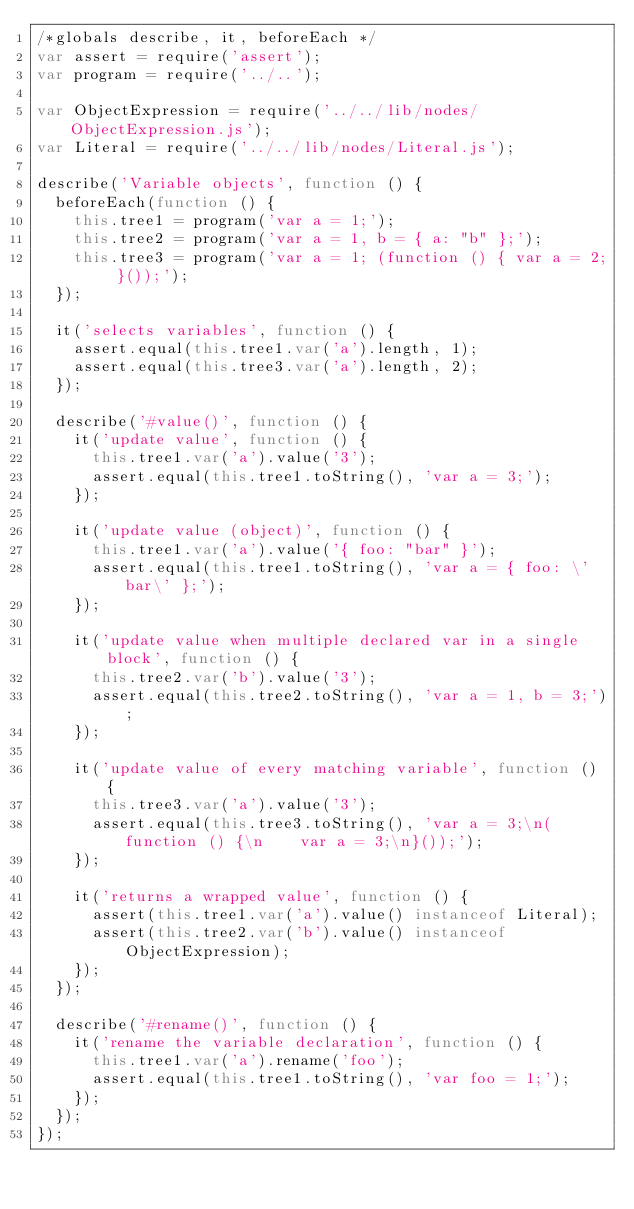<code> <loc_0><loc_0><loc_500><loc_500><_JavaScript_>/*globals describe, it, beforeEach */
var assert = require('assert');
var program = require('../..');

var ObjectExpression = require('../../lib/nodes/ObjectExpression.js');
var Literal = require('../../lib/nodes/Literal.js');

describe('Variable objects', function () {
  beforeEach(function () {
    this.tree1 = program('var a = 1;');
    this.tree2 = program('var a = 1, b = { a: "b" };');
    this.tree3 = program('var a = 1; (function () { var a = 2; }());');
  });

  it('selects variables', function () {
    assert.equal(this.tree1.var('a').length, 1);
    assert.equal(this.tree3.var('a').length, 2);
  });

  describe('#value()', function () {
    it('update value', function () {
      this.tree1.var('a').value('3');
      assert.equal(this.tree1.toString(), 'var a = 3;');
    });

    it('update value (object)', function () {
      this.tree1.var('a').value('{ foo: "bar" }');
      assert.equal(this.tree1.toString(), 'var a = { foo: \'bar\' };');
    });

    it('update value when multiple declared var in a single block', function () {
      this.tree2.var('b').value('3');
      assert.equal(this.tree2.toString(), 'var a = 1, b = 3;');
    });

    it('update value of every matching variable', function () {
      this.tree3.var('a').value('3');
      assert.equal(this.tree3.toString(), 'var a = 3;\n(function () {\n    var a = 3;\n}());');
    });

    it('returns a wrapped value', function () {
      assert(this.tree1.var('a').value() instanceof Literal);
      assert(this.tree2.var('b').value() instanceof ObjectExpression);
    });
  });

  describe('#rename()', function () {
    it('rename the variable declaration', function () {
      this.tree1.var('a').rename('foo');
      assert.equal(this.tree1.toString(), 'var foo = 1;');
    });
  });
});
</code> 